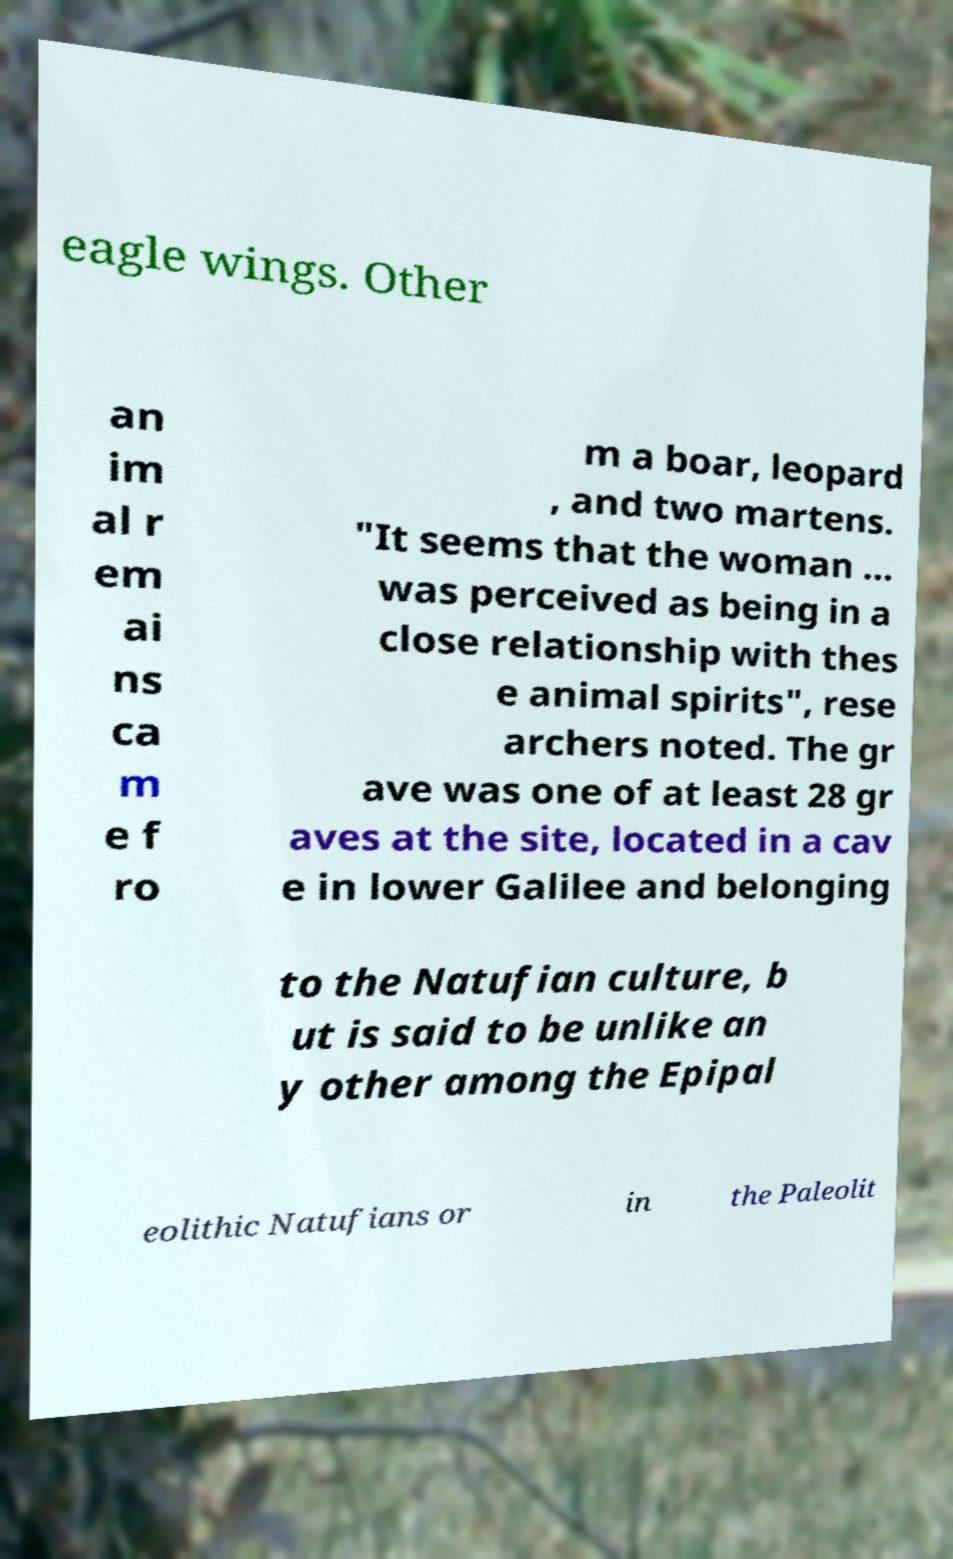For documentation purposes, I need the text within this image transcribed. Could you provide that? eagle wings. Other an im al r em ai ns ca m e f ro m a boar, leopard , and two martens. "It seems that the woman … was perceived as being in a close relationship with thes e animal spirits", rese archers noted. The gr ave was one of at least 28 gr aves at the site, located in a cav e in lower Galilee and belonging to the Natufian culture, b ut is said to be unlike an y other among the Epipal eolithic Natufians or in the Paleolit 